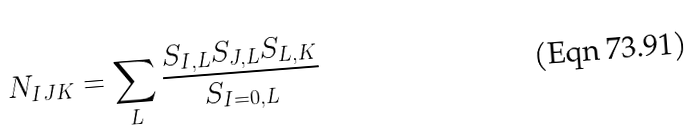Convert formula to latex. <formula><loc_0><loc_0><loc_500><loc_500>N _ { I J K } = \sum _ { L } { \frac { { S _ { I , L } S _ { J , L } S _ { L , K } } } { S _ { I = 0 , L } } }</formula> 